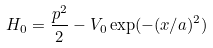<formula> <loc_0><loc_0><loc_500><loc_500>H _ { 0 } = \frac { p ^ { 2 } } { 2 } - V _ { 0 } \exp ( - ( x / a ) ^ { 2 } )</formula> 